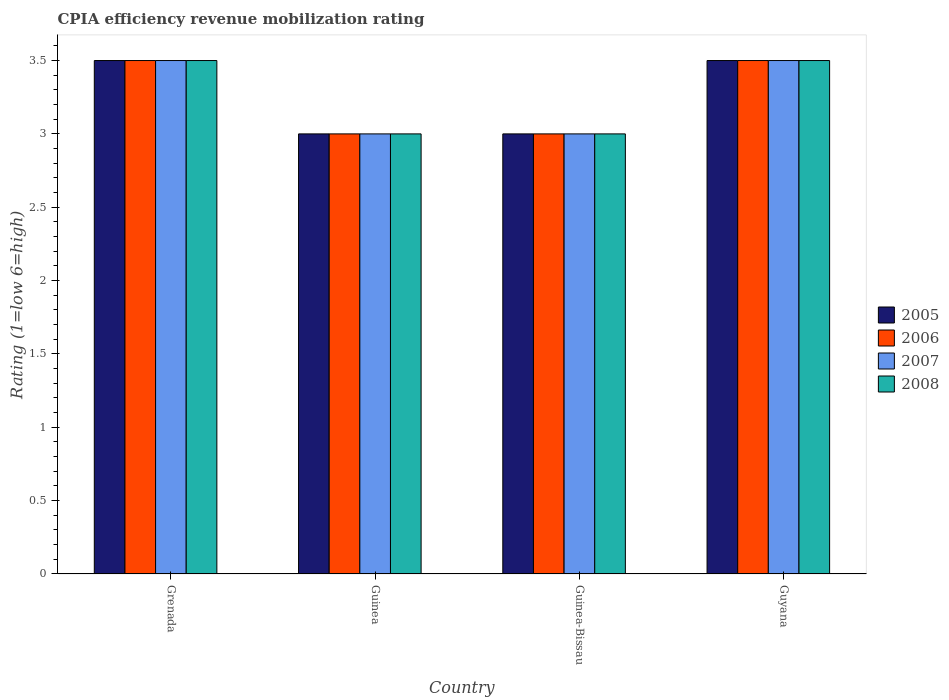How many groups of bars are there?
Offer a very short reply. 4. Are the number of bars per tick equal to the number of legend labels?
Offer a very short reply. Yes. Are the number of bars on each tick of the X-axis equal?
Ensure brevity in your answer.  Yes. What is the label of the 1st group of bars from the left?
Keep it short and to the point. Grenada. In how many cases, is the number of bars for a given country not equal to the number of legend labels?
Your answer should be compact. 0. What is the CPIA rating in 2006 in Guinea-Bissau?
Provide a short and direct response. 3. In which country was the CPIA rating in 2006 maximum?
Keep it short and to the point. Grenada. In which country was the CPIA rating in 2008 minimum?
Your response must be concise. Guinea. What is the difference between the CPIA rating in 2007 in Grenada and that in Guinea-Bissau?
Your response must be concise. 0.5. In how many countries, is the CPIA rating in 2007 greater than 0.2?
Offer a very short reply. 4. What is the ratio of the CPIA rating in 2005 in Grenada to that in Guinea-Bissau?
Give a very brief answer. 1.17. Is the difference between the CPIA rating in 2006 in Grenada and Guinea greater than the difference between the CPIA rating in 2007 in Grenada and Guinea?
Give a very brief answer. No. What is the difference between the highest and the second highest CPIA rating in 2007?
Your answer should be compact. -0.5. What does the 4th bar from the right in Guinea-Bissau represents?
Make the answer very short. 2005. How many bars are there?
Offer a very short reply. 16. How many countries are there in the graph?
Make the answer very short. 4. Are the values on the major ticks of Y-axis written in scientific E-notation?
Your response must be concise. No. Does the graph contain any zero values?
Provide a short and direct response. No. Does the graph contain grids?
Give a very brief answer. No. Where does the legend appear in the graph?
Your response must be concise. Center right. How many legend labels are there?
Offer a terse response. 4. What is the title of the graph?
Offer a very short reply. CPIA efficiency revenue mobilization rating. What is the label or title of the X-axis?
Offer a terse response. Country. What is the label or title of the Y-axis?
Your answer should be very brief. Rating (1=low 6=high). What is the Rating (1=low 6=high) in 2005 in Grenada?
Provide a succinct answer. 3.5. What is the Rating (1=low 6=high) of 2006 in Grenada?
Your answer should be very brief. 3.5. What is the Rating (1=low 6=high) of 2008 in Guinea?
Offer a very short reply. 3. What is the Rating (1=low 6=high) of 2005 in Guinea-Bissau?
Your answer should be compact. 3. What is the Rating (1=low 6=high) of 2006 in Guinea-Bissau?
Your answer should be very brief. 3. What is the Rating (1=low 6=high) in 2008 in Guinea-Bissau?
Provide a short and direct response. 3. What is the Rating (1=low 6=high) of 2005 in Guyana?
Keep it short and to the point. 3.5. What is the Rating (1=low 6=high) of 2006 in Guyana?
Give a very brief answer. 3.5. What is the Rating (1=low 6=high) in 2007 in Guyana?
Provide a short and direct response. 3.5. Across all countries, what is the maximum Rating (1=low 6=high) of 2006?
Your answer should be very brief. 3.5. Across all countries, what is the maximum Rating (1=low 6=high) of 2007?
Offer a terse response. 3.5. What is the total Rating (1=low 6=high) of 2005 in the graph?
Your answer should be compact. 13. What is the total Rating (1=low 6=high) of 2006 in the graph?
Provide a short and direct response. 13. What is the difference between the Rating (1=low 6=high) in 2005 in Grenada and that in Guinea?
Your response must be concise. 0.5. What is the difference between the Rating (1=low 6=high) of 2006 in Grenada and that in Guinea?
Keep it short and to the point. 0.5. What is the difference between the Rating (1=low 6=high) in 2008 in Grenada and that in Guinea?
Your response must be concise. 0.5. What is the difference between the Rating (1=low 6=high) in 2006 in Grenada and that in Guinea-Bissau?
Offer a terse response. 0.5. What is the difference between the Rating (1=low 6=high) of 2007 in Grenada and that in Guinea-Bissau?
Keep it short and to the point. 0.5. What is the difference between the Rating (1=low 6=high) of 2008 in Grenada and that in Guinea-Bissau?
Your response must be concise. 0.5. What is the difference between the Rating (1=low 6=high) in 2008 in Grenada and that in Guyana?
Offer a very short reply. 0. What is the difference between the Rating (1=low 6=high) of 2005 in Guinea and that in Guinea-Bissau?
Keep it short and to the point. 0. What is the difference between the Rating (1=low 6=high) of 2006 in Guinea and that in Guinea-Bissau?
Offer a terse response. 0. What is the difference between the Rating (1=low 6=high) of 2007 in Guinea and that in Guinea-Bissau?
Provide a succinct answer. 0. What is the difference between the Rating (1=low 6=high) in 2005 in Guinea and that in Guyana?
Provide a succinct answer. -0.5. What is the difference between the Rating (1=low 6=high) of 2007 in Guinea and that in Guyana?
Provide a short and direct response. -0.5. What is the difference between the Rating (1=low 6=high) in 2005 in Guinea-Bissau and that in Guyana?
Give a very brief answer. -0.5. What is the difference between the Rating (1=low 6=high) of 2008 in Guinea-Bissau and that in Guyana?
Give a very brief answer. -0.5. What is the difference between the Rating (1=low 6=high) in 2005 in Grenada and the Rating (1=low 6=high) in 2007 in Guinea?
Offer a terse response. 0.5. What is the difference between the Rating (1=low 6=high) in 2006 in Grenada and the Rating (1=low 6=high) in 2007 in Guinea?
Your answer should be compact. 0.5. What is the difference between the Rating (1=low 6=high) in 2006 in Grenada and the Rating (1=low 6=high) in 2008 in Guinea?
Give a very brief answer. 0.5. What is the difference between the Rating (1=low 6=high) of 2005 in Grenada and the Rating (1=low 6=high) of 2006 in Guinea-Bissau?
Ensure brevity in your answer.  0.5. What is the difference between the Rating (1=low 6=high) in 2005 in Grenada and the Rating (1=low 6=high) in 2007 in Guinea-Bissau?
Your answer should be compact. 0.5. What is the difference between the Rating (1=low 6=high) of 2007 in Grenada and the Rating (1=low 6=high) of 2008 in Guinea-Bissau?
Your answer should be very brief. 0.5. What is the difference between the Rating (1=low 6=high) in 2005 in Grenada and the Rating (1=low 6=high) in 2006 in Guyana?
Offer a very short reply. 0. What is the difference between the Rating (1=low 6=high) of 2006 in Grenada and the Rating (1=low 6=high) of 2008 in Guyana?
Keep it short and to the point. 0. What is the difference between the Rating (1=low 6=high) in 2005 in Guinea and the Rating (1=low 6=high) in 2006 in Guinea-Bissau?
Your response must be concise. 0. What is the difference between the Rating (1=low 6=high) of 2005 in Guinea and the Rating (1=low 6=high) of 2007 in Guinea-Bissau?
Offer a very short reply. 0. What is the difference between the Rating (1=low 6=high) in 2006 in Guinea and the Rating (1=low 6=high) in 2007 in Guinea-Bissau?
Keep it short and to the point. 0. What is the difference between the Rating (1=low 6=high) in 2007 in Guinea and the Rating (1=low 6=high) in 2008 in Guinea-Bissau?
Offer a very short reply. 0. What is the difference between the Rating (1=low 6=high) of 2005 in Guinea and the Rating (1=low 6=high) of 2006 in Guyana?
Make the answer very short. -0.5. What is the difference between the Rating (1=low 6=high) in 2005 in Guinea and the Rating (1=low 6=high) in 2008 in Guyana?
Offer a very short reply. -0.5. What is the difference between the Rating (1=low 6=high) in 2006 in Guinea and the Rating (1=low 6=high) in 2007 in Guyana?
Your response must be concise. -0.5. What is the difference between the Rating (1=low 6=high) in 2005 in Guinea-Bissau and the Rating (1=low 6=high) in 2007 in Guyana?
Give a very brief answer. -0.5. What is the difference between the Rating (1=low 6=high) in 2005 in Guinea-Bissau and the Rating (1=low 6=high) in 2008 in Guyana?
Provide a succinct answer. -0.5. What is the difference between the Rating (1=low 6=high) in 2006 in Guinea-Bissau and the Rating (1=low 6=high) in 2008 in Guyana?
Your answer should be compact. -0.5. What is the average Rating (1=low 6=high) in 2005 per country?
Give a very brief answer. 3.25. What is the average Rating (1=low 6=high) in 2006 per country?
Your answer should be very brief. 3.25. What is the average Rating (1=low 6=high) in 2007 per country?
Offer a very short reply. 3.25. What is the difference between the Rating (1=low 6=high) of 2005 and Rating (1=low 6=high) of 2006 in Grenada?
Offer a terse response. 0. What is the difference between the Rating (1=low 6=high) in 2005 and Rating (1=low 6=high) in 2008 in Grenada?
Give a very brief answer. 0. What is the difference between the Rating (1=low 6=high) in 2006 and Rating (1=low 6=high) in 2008 in Grenada?
Offer a very short reply. 0. What is the difference between the Rating (1=low 6=high) in 2007 and Rating (1=low 6=high) in 2008 in Grenada?
Offer a terse response. 0. What is the difference between the Rating (1=low 6=high) of 2005 and Rating (1=low 6=high) of 2006 in Guinea?
Your answer should be compact. 0. What is the difference between the Rating (1=low 6=high) of 2005 and Rating (1=low 6=high) of 2008 in Guinea?
Provide a short and direct response. 0. What is the difference between the Rating (1=low 6=high) of 2005 and Rating (1=low 6=high) of 2006 in Guinea-Bissau?
Your answer should be compact. 0. What is the difference between the Rating (1=low 6=high) of 2006 and Rating (1=low 6=high) of 2008 in Guinea-Bissau?
Your answer should be very brief. 0. What is the difference between the Rating (1=low 6=high) in 2007 and Rating (1=low 6=high) in 2008 in Guinea-Bissau?
Your answer should be very brief. 0. What is the difference between the Rating (1=low 6=high) in 2005 and Rating (1=low 6=high) in 2006 in Guyana?
Your answer should be very brief. 0. What is the difference between the Rating (1=low 6=high) in 2005 and Rating (1=low 6=high) in 2007 in Guyana?
Your answer should be very brief. 0. What is the difference between the Rating (1=low 6=high) of 2005 and Rating (1=low 6=high) of 2008 in Guyana?
Ensure brevity in your answer.  0. What is the difference between the Rating (1=low 6=high) of 2006 and Rating (1=low 6=high) of 2007 in Guyana?
Your answer should be very brief. 0. What is the ratio of the Rating (1=low 6=high) of 2005 in Grenada to that in Guinea?
Ensure brevity in your answer.  1.17. What is the ratio of the Rating (1=low 6=high) of 2007 in Grenada to that in Guinea?
Give a very brief answer. 1.17. What is the ratio of the Rating (1=low 6=high) of 2005 in Grenada to that in Guinea-Bissau?
Provide a short and direct response. 1.17. What is the ratio of the Rating (1=low 6=high) of 2007 in Grenada to that in Guinea-Bissau?
Provide a short and direct response. 1.17. What is the ratio of the Rating (1=low 6=high) in 2006 in Grenada to that in Guyana?
Keep it short and to the point. 1. What is the ratio of the Rating (1=low 6=high) in 2007 in Grenada to that in Guyana?
Offer a terse response. 1. What is the ratio of the Rating (1=low 6=high) in 2008 in Grenada to that in Guyana?
Make the answer very short. 1. What is the ratio of the Rating (1=low 6=high) in 2005 in Guinea to that in Guinea-Bissau?
Your answer should be compact. 1. What is the ratio of the Rating (1=low 6=high) of 2007 in Guinea to that in Guinea-Bissau?
Ensure brevity in your answer.  1. What is the ratio of the Rating (1=low 6=high) of 2005 in Guinea to that in Guyana?
Provide a short and direct response. 0.86. What is the ratio of the Rating (1=low 6=high) in 2006 in Guinea to that in Guyana?
Ensure brevity in your answer.  0.86. What is the ratio of the Rating (1=low 6=high) in 2007 in Guinea to that in Guyana?
Your response must be concise. 0.86. What is the ratio of the Rating (1=low 6=high) in 2008 in Guinea to that in Guyana?
Ensure brevity in your answer.  0.86. What is the ratio of the Rating (1=low 6=high) of 2005 in Guinea-Bissau to that in Guyana?
Your answer should be very brief. 0.86. What is the ratio of the Rating (1=low 6=high) in 2006 in Guinea-Bissau to that in Guyana?
Offer a very short reply. 0.86. What is the ratio of the Rating (1=low 6=high) of 2007 in Guinea-Bissau to that in Guyana?
Your answer should be compact. 0.86. What is the ratio of the Rating (1=low 6=high) in 2008 in Guinea-Bissau to that in Guyana?
Ensure brevity in your answer.  0.86. What is the difference between the highest and the second highest Rating (1=low 6=high) in 2005?
Offer a very short reply. 0. What is the difference between the highest and the second highest Rating (1=low 6=high) of 2007?
Offer a very short reply. 0. What is the difference between the highest and the second highest Rating (1=low 6=high) of 2008?
Offer a very short reply. 0. What is the difference between the highest and the lowest Rating (1=low 6=high) of 2008?
Your answer should be very brief. 0.5. 